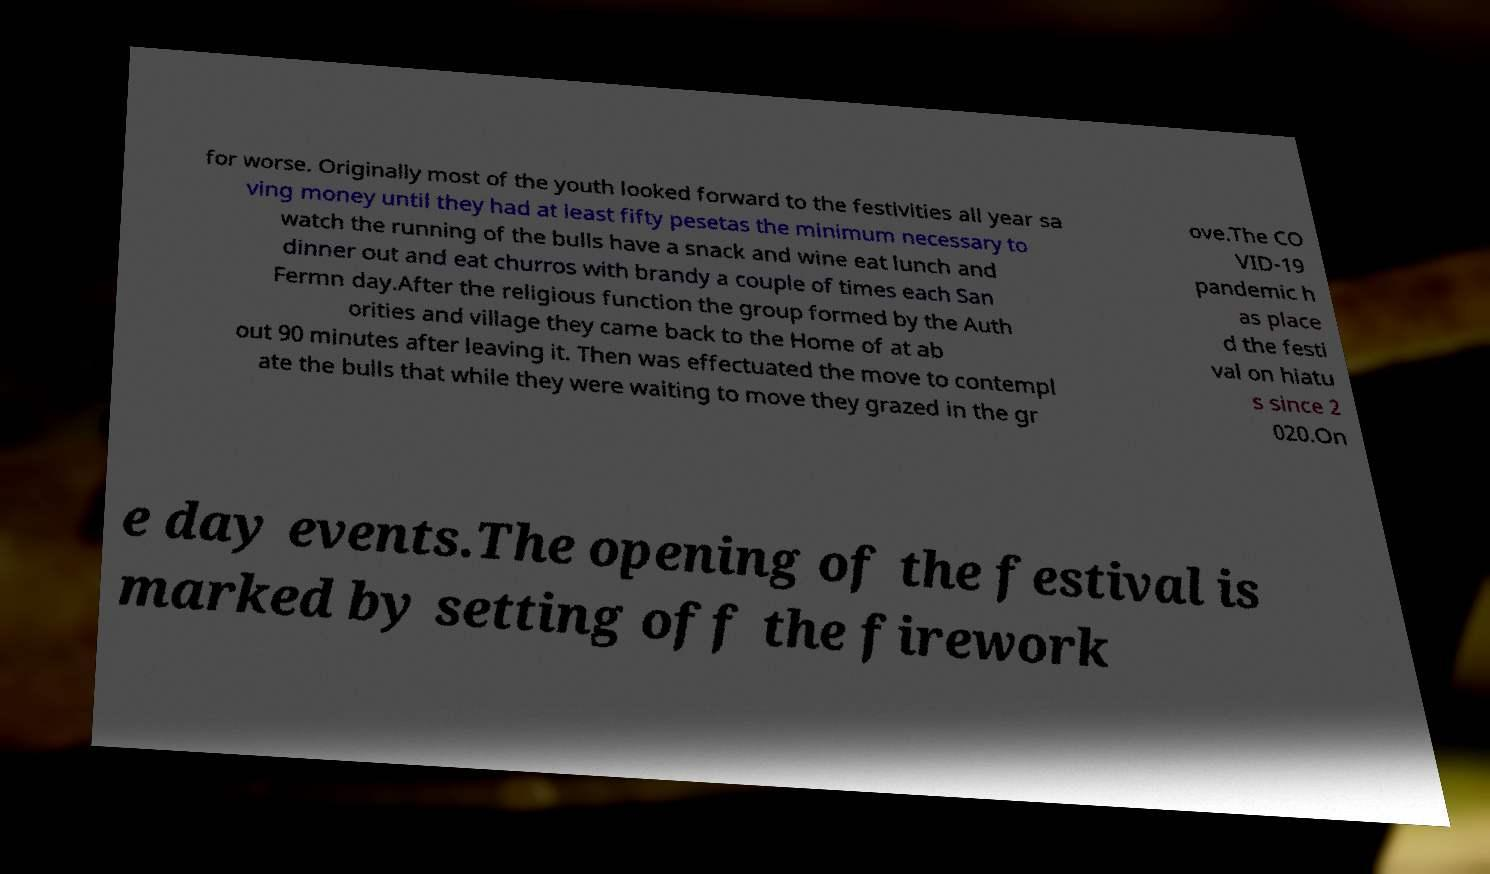There's text embedded in this image that I need extracted. Can you transcribe it verbatim? for worse. Originally most of the youth looked forward to the festivities all year sa ving money until they had at least fifty pesetas the minimum necessary to watch the running of the bulls have a snack and wine eat lunch and dinner out and eat churros with brandy a couple of times each San Fermn day.After the religious function the group formed by the Auth orities and village they came back to the Home of at ab out 90 minutes after leaving it. Then was effectuated the move to contempl ate the bulls that while they were waiting to move they grazed in the gr ove.The CO VID-19 pandemic h as place d the festi val on hiatu s since 2 020.On e day events.The opening of the festival is marked by setting off the firework 